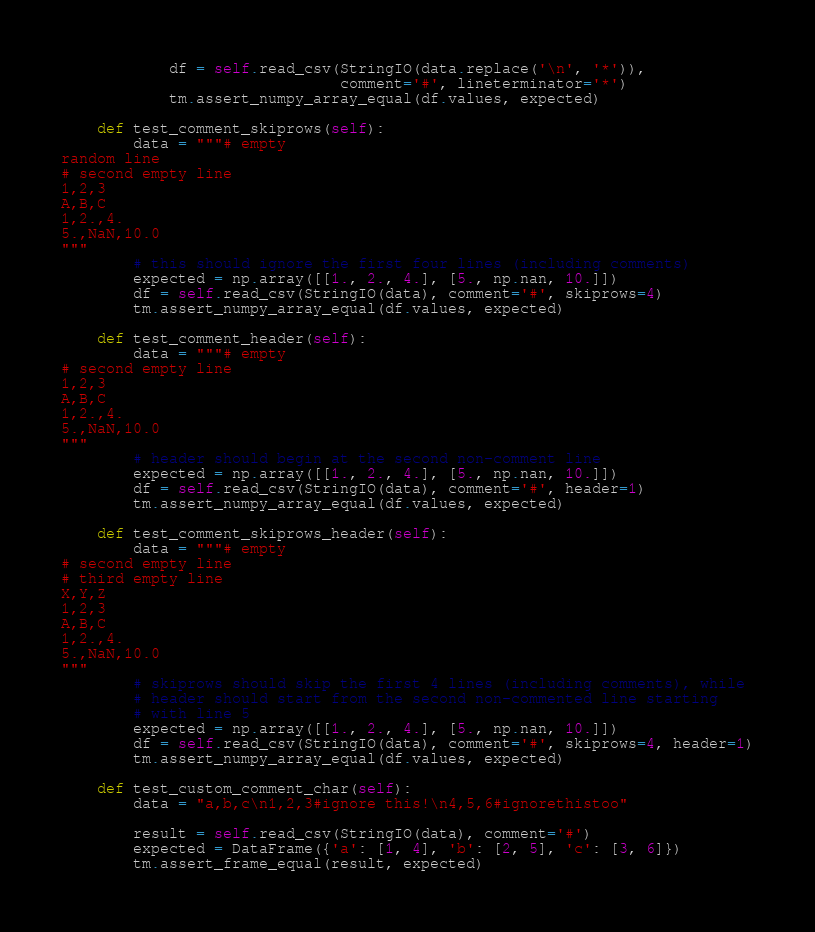Convert code to text. <code><loc_0><loc_0><loc_500><loc_500><_Python_>            df = self.read_csv(StringIO(data.replace('\n', '*')),
                               comment='#', lineterminator='*')
            tm.assert_numpy_array_equal(df.values, expected)

    def test_comment_skiprows(self):
        data = """# empty
random line
# second empty line
1,2,3
A,B,C
1,2.,4.
5.,NaN,10.0
"""
        # this should ignore the first four lines (including comments)
        expected = np.array([[1., 2., 4.], [5., np.nan, 10.]])
        df = self.read_csv(StringIO(data), comment='#', skiprows=4)
        tm.assert_numpy_array_equal(df.values, expected)

    def test_comment_header(self):
        data = """# empty
# second empty line
1,2,3
A,B,C
1,2.,4.
5.,NaN,10.0
"""
        # header should begin at the second non-comment line
        expected = np.array([[1., 2., 4.], [5., np.nan, 10.]])
        df = self.read_csv(StringIO(data), comment='#', header=1)
        tm.assert_numpy_array_equal(df.values, expected)

    def test_comment_skiprows_header(self):
        data = """# empty
# second empty line
# third empty line
X,Y,Z
1,2,3
A,B,C
1,2.,4.
5.,NaN,10.0
"""
        # skiprows should skip the first 4 lines (including comments), while
        # header should start from the second non-commented line starting
        # with line 5
        expected = np.array([[1., 2., 4.], [5., np.nan, 10.]])
        df = self.read_csv(StringIO(data), comment='#', skiprows=4, header=1)
        tm.assert_numpy_array_equal(df.values, expected)

    def test_custom_comment_char(self):
        data = "a,b,c\n1,2,3#ignore this!\n4,5,6#ignorethistoo"

        result = self.read_csv(StringIO(data), comment='#')
        expected = DataFrame({'a': [1, 4], 'b': [2, 5], 'c': [3, 6]})
        tm.assert_frame_equal(result, expected)
</code> 